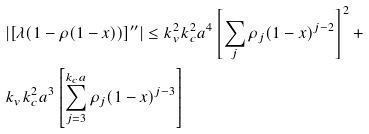Convert formula to latex. <formula><loc_0><loc_0><loc_500><loc_500>& { \left | [ \lambda ( 1 - \rho ( 1 - x ) ) ] ^ { \prime \prime } \right | \leq k _ { v } ^ { 2 } k _ { c } ^ { 2 } a ^ { 4 } \left [ \sum _ { j } \rho _ { j } ( 1 - x ) ^ { j - 2 } \right ] ^ { 2 } + } \\ & { k _ { v } k _ { c } ^ { 2 } a ^ { 3 } \left [ \sum _ { j = 3 } ^ { k _ { c } a } \rho _ { j } ( 1 - x ) ^ { j - 3 } \right ] }</formula> 